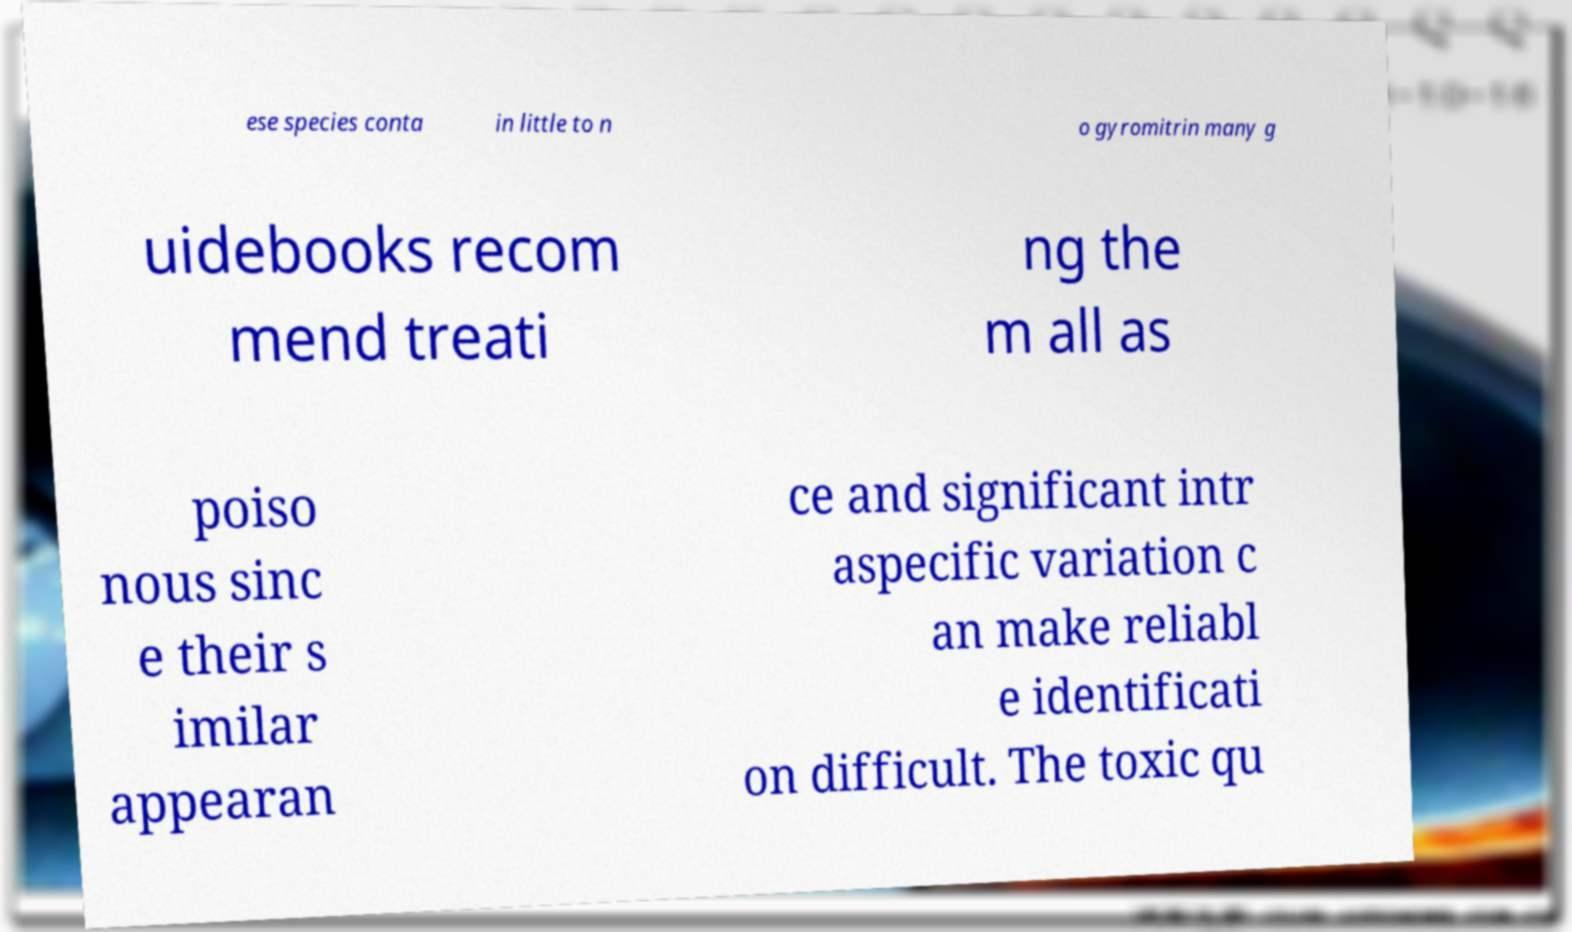I need the written content from this picture converted into text. Can you do that? ese species conta in little to n o gyromitrin many g uidebooks recom mend treati ng the m all as poiso nous sinc e their s imilar appearan ce and significant intr aspecific variation c an make reliabl e identificati on difficult. The toxic qu 